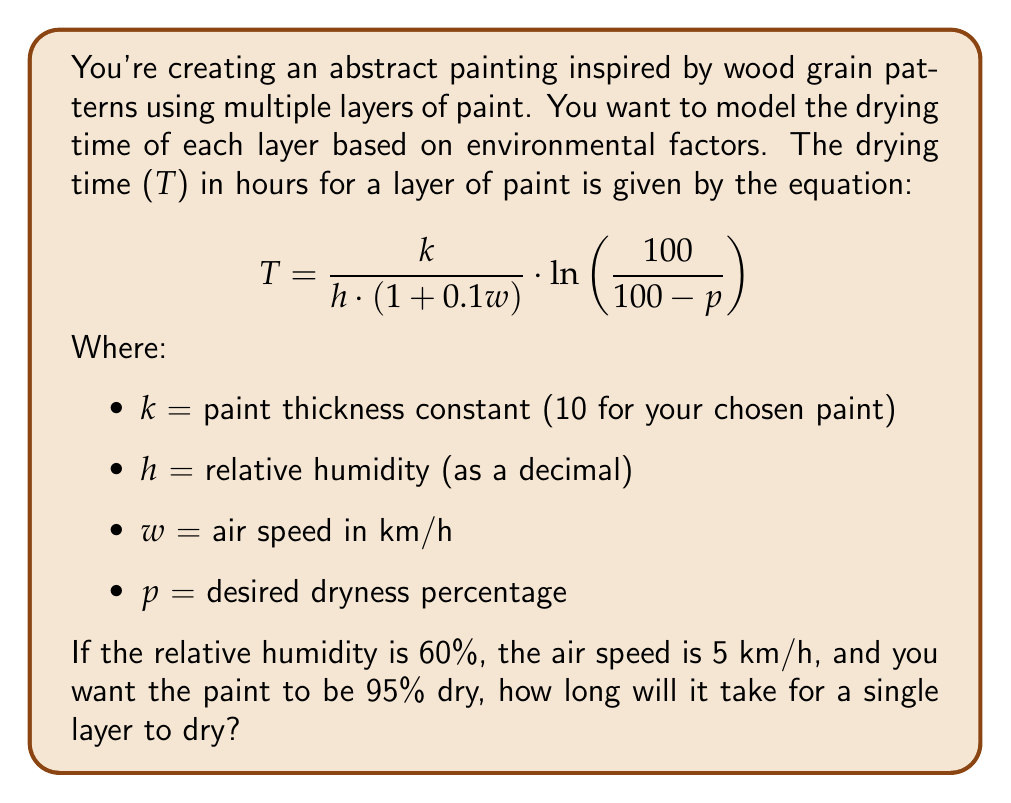Give your solution to this math problem. To solve this problem, we need to substitute the given values into the equation and calculate the result. Let's break it down step by step:

1. Given values:
   $k = 10$ (paint thickness constant)
   $h = 0.60$ (60% relative humidity as a decimal)
   $w = 5$ km/h (air speed)
   $p = 95$ (desired dryness percentage)

2. Substitute these values into the equation:

   $$ T = \frac{10}{0.60 \cdot (1 + 0.1 \cdot 5)} \cdot \ln\left(\frac{100}{100-95}\right) $$

3. Simplify the denominator inside the fraction:
   $0.60 \cdot (1 + 0.5) = 0.60 \cdot 1.5 = 0.90$

   $$ T = \frac{10}{0.90} \cdot \ln\left(\frac{100}{5}\right) $$

4. Simplify the fraction inside the logarithm:
   $\frac{100}{5} = 20$

   $$ T = \frac{10}{0.90} \cdot \ln(20) $$

5. Calculate the natural logarithm:
   $\ln(20) \approx 2.9957$

   $$ T = \frac{10}{0.90} \cdot 2.9957 $$

6. Multiply the fraction by the logarithm result:

   $$ T = 11.1111 \cdot 2.9957 $$

7. Calculate the final result:

   $$ T \approx 33.2856 $$

Therefore, it will take approximately 33.29 hours for a single layer of paint to reach 95% dryness under the given environmental conditions.
Answer: 33.29 hours 